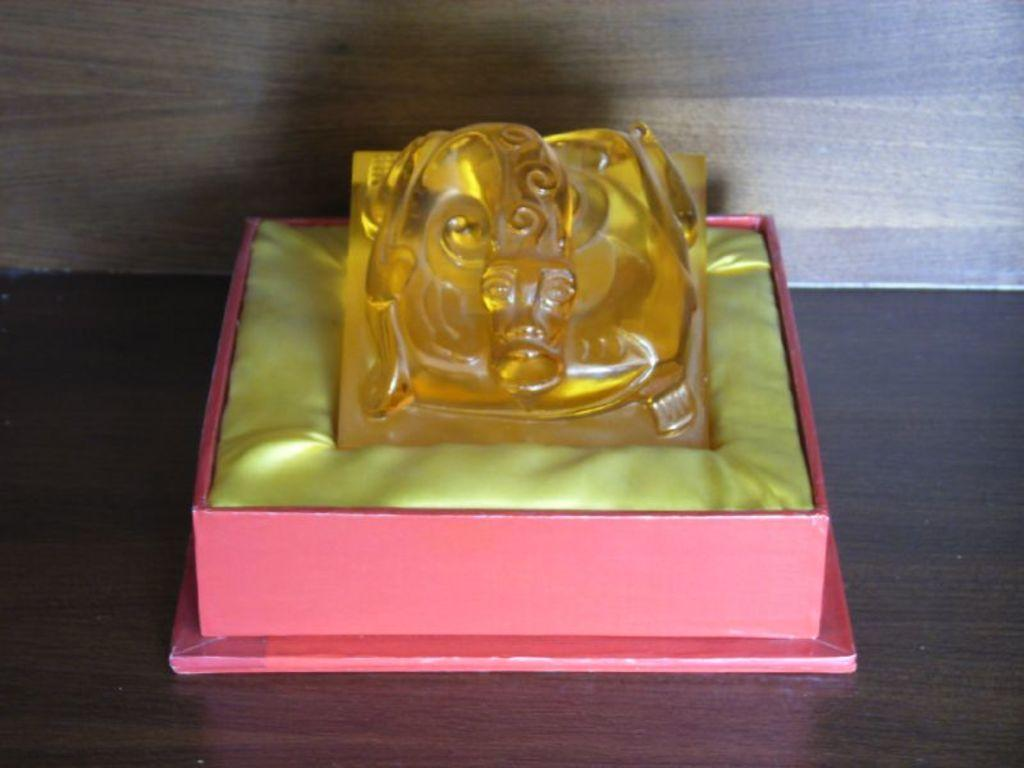What is the main object in the image? There is a box in the image. Can you describe the position of the object in the image? There is an object on a wooden platform in the image. What type of stage is visible in the image? There is no stage present in the image; it only features a box on a wooden platform. What time of day is depicted in the image? The time of day cannot be determined from the image, as there are no indicators of time present. 